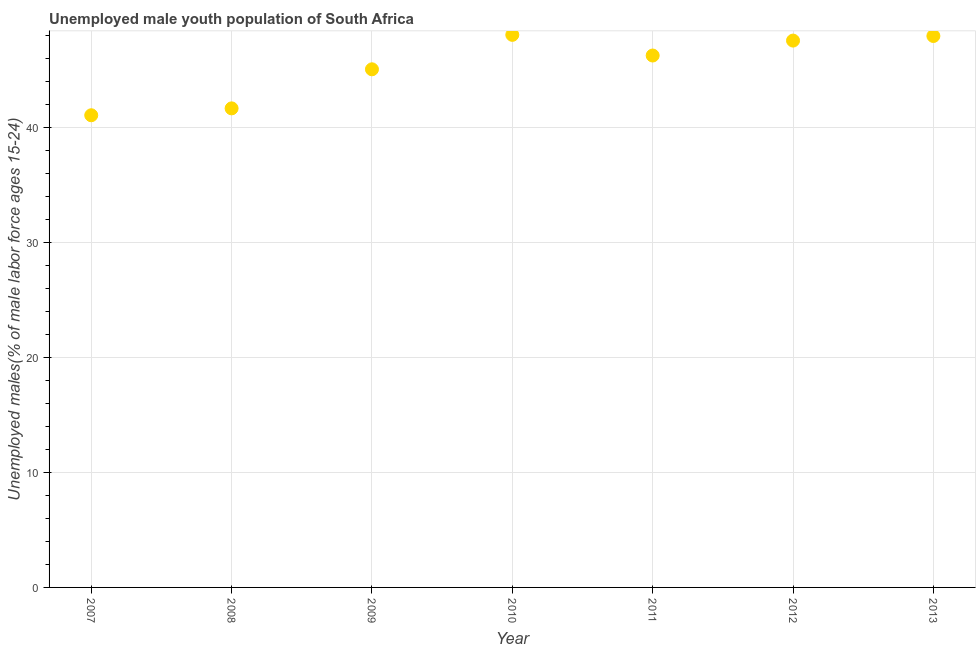What is the unemployed male youth in 2013?
Your response must be concise. 48. Across all years, what is the maximum unemployed male youth?
Provide a succinct answer. 48.1. Across all years, what is the minimum unemployed male youth?
Provide a short and direct response. 41.1. In which year was the unemployed male youth minimum?
Provide a succinct answer. 2007. What is the sum of the unemployed male youth?
Your response must be concise. 317.9. What is the difference between the unemployed male youth in 2011 and 2013?
Offer a terse response. -1.7. What is the average unemployed male youth per year?
Your answer should be very brief. 45.41. What is the median unemployed male youth?
Make the answer very short. 46.3. Do a majority of the years between 2011 and 2012 (inclusive) have unemployed male youth greater than 2 %?
Your answer should be very brief. Yes. What is the ratio of the unemployed male youth in 2007 to that in 2013?
Make the answer very short. 0.86. Is the unemployed male youth in 2012 less than that in 2013?
Offer a very short reply. Yes. What is the difference between the highest and the second highest unemployed male youth?
Offer a terse response. 0.1. Is the sum of the unemployed male youth in 2007 and 2010 greater than the maximum unemployed male youth across all years?
Offer a very short reply. Yes. In how many years, is the unemployed male youth greater than the average unemployed male youth taken over all years?
Your answer should be compact. 4. Does the unemployed male youth monotonically increase over the years?
Make the answer very short. No. How many dotlines are there?
Your response must be concise. 1. How many years are there in the graph?
Make the answer very short. 7. What is the title of the graph?
Make the answer very short. Unemployed male youth population of South Africa. What is the label or title of the X-axis?
Offer a very short reply. Year. What is the label or title of the Y-axis?
Keep it short and to the point. Unemployed males(% of male labor force ages 15-24). What is the Unemployed males(% of male labor force ages 15-24) in 2007?
Ensure brevity in your answer.  41.1. What is the Unemployed males(% of male labor force ages 15-24) in 2008?
Offer a terse response. 41.7. What is the Unemployed males(% of male labor force ages 15-24) in 2009?
Give a very brief answer. 45.1. What is the Unemployed males(% of male labor force ages 15-24) in 2010?
Ensure brevity in your answer.  48.1. What is the Unemployed males(% of male labor force ages 15-24) in 2011?
Give a very brief answer. 46.3. What is the Unemployed males(% of male labor force ages 15-24) in 2012?
Keep it short and to the point. 47.6. What is the Unemployed males(% of male labor force ages 15-24) in 2013?
Your answer should be compact. 48. What is the difference between the Unemployed males(% of male labor force ages 15-24) in 2007 and 2008?
Offer a very short reply. -0.6. What is the difference between the Unemployed males(% of male labor force ages 15-24) in 2007 and 2010?
Give a very brief answer. -7. What is the difference between the Unemployed males(% of male labor force ages 15-24) in 2007 and 2011?
Offer a very short reply. -5.2. What is the difference between the Unemployed males(% of male labor force ages 15-24) in 2007 and 2012?
Offer a terse response. -6.5. What is the difference between the Unemployed males(% of male labor force ages 15-24) in 2008 and 2009?
Your answer should be very brief. -3.4. What is the difference between the Unemployed males(% of male labor force ages 15-24) in 2008 and 2011?
Your answer should be compact. -4.6. What is the difference between the Unemployed males(% of male labor force ages 15-24) in 2008 and 2012?
Your answer should be very brief. -5.9. What is the difference between the Unemployed males(% of male labor force ages 15-24) in 2009 and 2012?
Your answer should be very brief. -2.5. What is the difference between the Unemployed males(% of male labor force ages 15-24) in 2010 and 2013?
Ensure brevity in your answer.  0.1. What is the difference between the Unemployed males(% of male labor force ages 15-24) in 2011 and 2012?
Offer a very short reply. -1.3. What is the ratio of the Unemployed males(% of male labor force ages 15-24) in 2007 to that in 2009?
Give a very brief answer. 0.91. What is the ratio of the Unemployed males(% of male labor force ages 15-24) in 2007 to that in 2010?
Provide a short and direct response. 0.85. What is the ratio of the Unemployed males(% of male labor force ages 15-24) in 2007 to that in 2011?
Your answer should be compact. 0.89. What is the ratio of the Unemployed males(% of male labor force ages 15-24) in 2007 to that in 2012?
Ensure brevity in your answer.  0.86. What is the ratio of the Unemployed males(% of male labor force ages 15-24) in 2007 to that in 2013?
Give a very brief answer. 0.86. What is the ratio of the Unemployed males(% of male labor force ages 15-24) in 2008 to that in 2009?
Provide a succinct answer. 0.93. What is the ratio of the Unemployed males(% of male labor force ages 15-24) in 2008 to that in 2010?
Provide a succinct answer. 0.87. What is the ratio of the Unemployed males(% of male labor force ages 15-24) in 2008 to that in 2011?
Your response must be concise. 0.9. What is the ratio of the Unemployed males(% of male labor force ages 15-24) in 2008 to that in 2012?
Offer a terse response. 0.88. What is the ratio of the Unemployed males(% of male labor force ages 15-24) in 2008 to that in 2013?
Offer a terse response. 0.87. What is the ratio of the Unemployed males(% of male labor force ages 15-24) in 2009 to that in 2010?
Give a very brief answer. 0.94. What is the ratio of the Unemployed males(% of male labor force ages 15-24) in 2009 to that in 2012?
Give a very brief answer. 0.95. What is the ratio of the Unemployed males(% of male labor force ages 15-24) in 2010 to that in 2011?
Keep it short and to the point. 1.04. What is the ratio of the Unemployed males(% of male labor force ages 15-24) in 2010 to that in 2012?
Your answer should be very brief. 1.01. What is the ratio of the Unemployed males(% of male labor force ages 15-24) in 2010 to that in 2013?
Your answer should be compact. 1. What is the ratio of the Unemployed males(% of male labor force ages 15-24) in 2012 to that in 2013?
Your answer should be very brief. 0.99. 